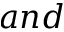<formula> <loc_0><loc_0><loc_500><loc_500>a n d</formula> 